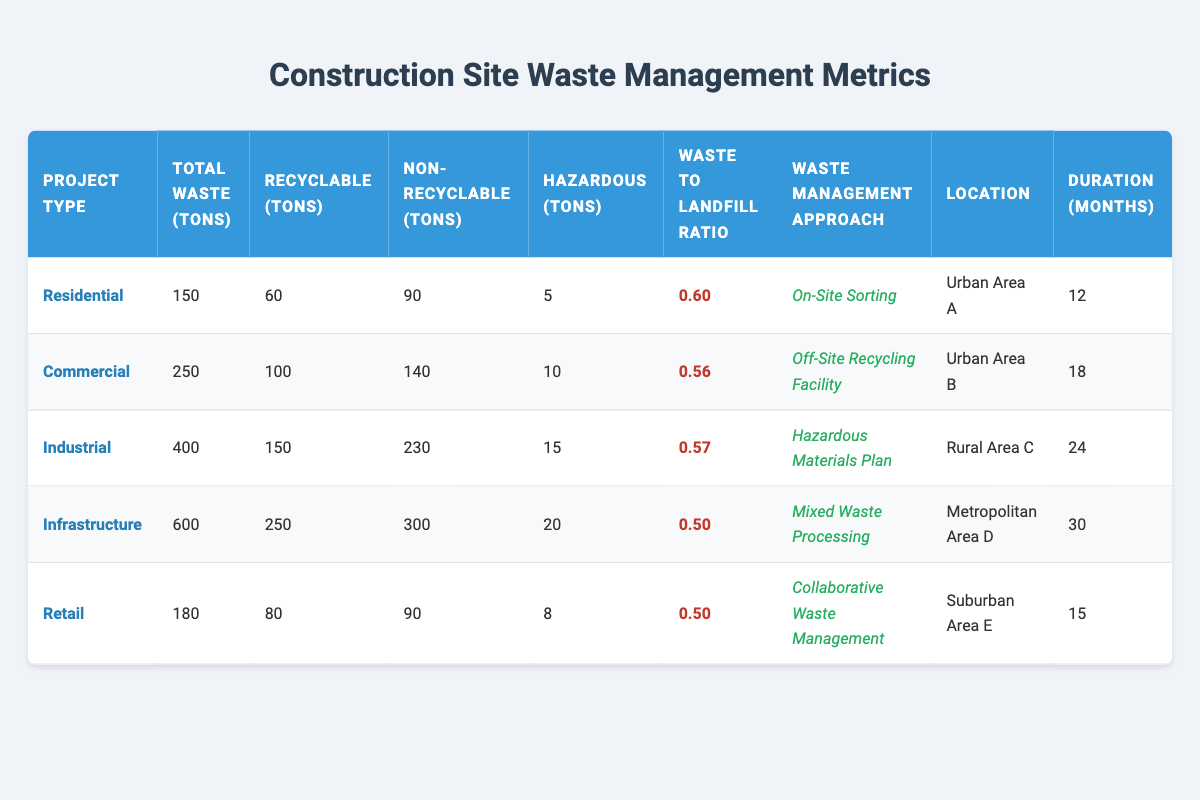What is the total waste generated for Industrial projects? The Industrial project type has a total waste generated of 400 tons listed in the table under "Total Waste (tons)."
Answer: 400 tons Which project type has the highest ratio of waste to landfill? The Residential project type has a waste to landfill ratio of 0.60, which is the highest ratio shown in the table.
Answer: 0.60 How many tons of recyclable materials are generated in Commercial projects? The Commercial project type lists 100 tons of recyclable materials in the "Recyclable (tons)" column.
Answer: 100 tons What is the difference in total waste generated between Infrastructure and Retail projects? Infrastructure generates 600 tons of waste while Retail generates 180 tons. The difference is calculated as 600 - 180 = 420 tons.
Answer: 420 tons Which project type generates the least amount of hazardous waste? The Residential project type generates the least hazardous waste with 5 tons, as per the "Hazardous (tons)" column.
Answer: Residential Which project type has the longest duration, and how many months is it? The Infrastructure project has the longest duration of 30 months listed in the "Duration (months)" column.
Answer: 30 months What is the average waste to landfill ratio across all project types? To find the average, sum the ratios (0.60 + 0.56 + 0.57 + 0.50 + 0.50 = 2.73) and divide by the number of project types (5). The average is 2.73 / 5 = 0.546.
Answer: 0.546 Is it true that the total waste generated is higher for Commercial projects than for Residential projects? Yes, the total waste for Commercial projects is 250 tons, which is higher than Residential's 150 tons.
Answer: Yes What percentage of the total waste generated in Industrial projects is recyclable? For Industrial projects, 150 tons of the total 400 tons of waste are recyclable. The percentage is calculated as (150 / 400) * 100 = 37.5%.
Answer: 37.5% How does the total waste generated in Urban Area B compare to that in Rural Area C? In Urban Area B (Commercial projects), total waste is 250 tons, while in Rural Area C (Industrial projects), it's 400 tons. Thus, Rural Area C has 150 tons more waste generated than Urban Area B.
Answer: 150 tons more in Rural Area C 